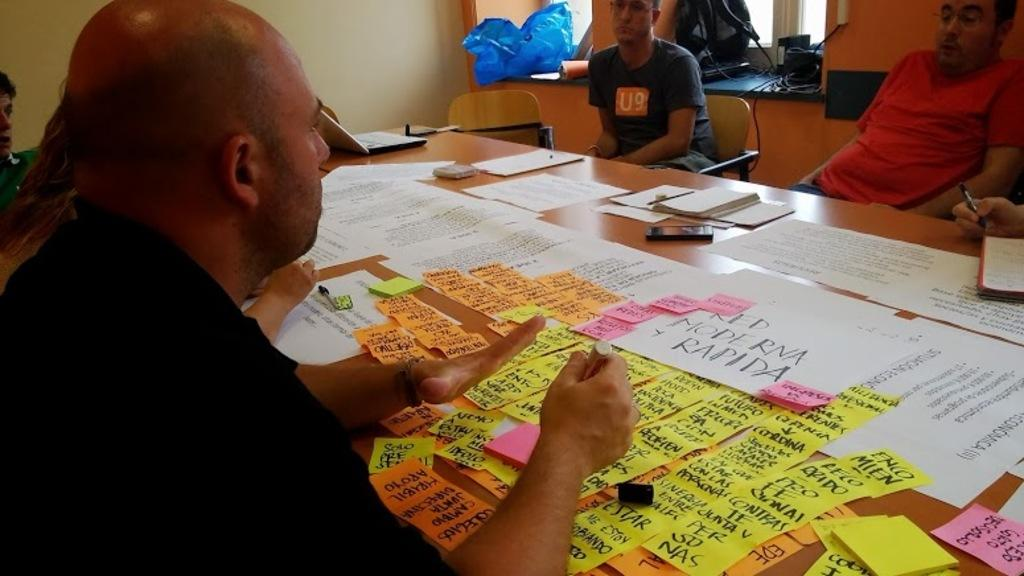What type of furniture is in the image? There is a table in the image. What is on the table? Papers are present on the table. Who is sitting around the table? There are people sitting on chairs around the table. What can be seen through the windows in the image? The presence of windows suggests that there might be a view or natural light coming in, but the specifics are not mentioned in the facts. What type of disgust can be seen on the people's faces in the image? There is no mention of any emotions or expressions on the people's faces in the image, so it cannot be determined if they are experiencing disgust or any other emotion. 